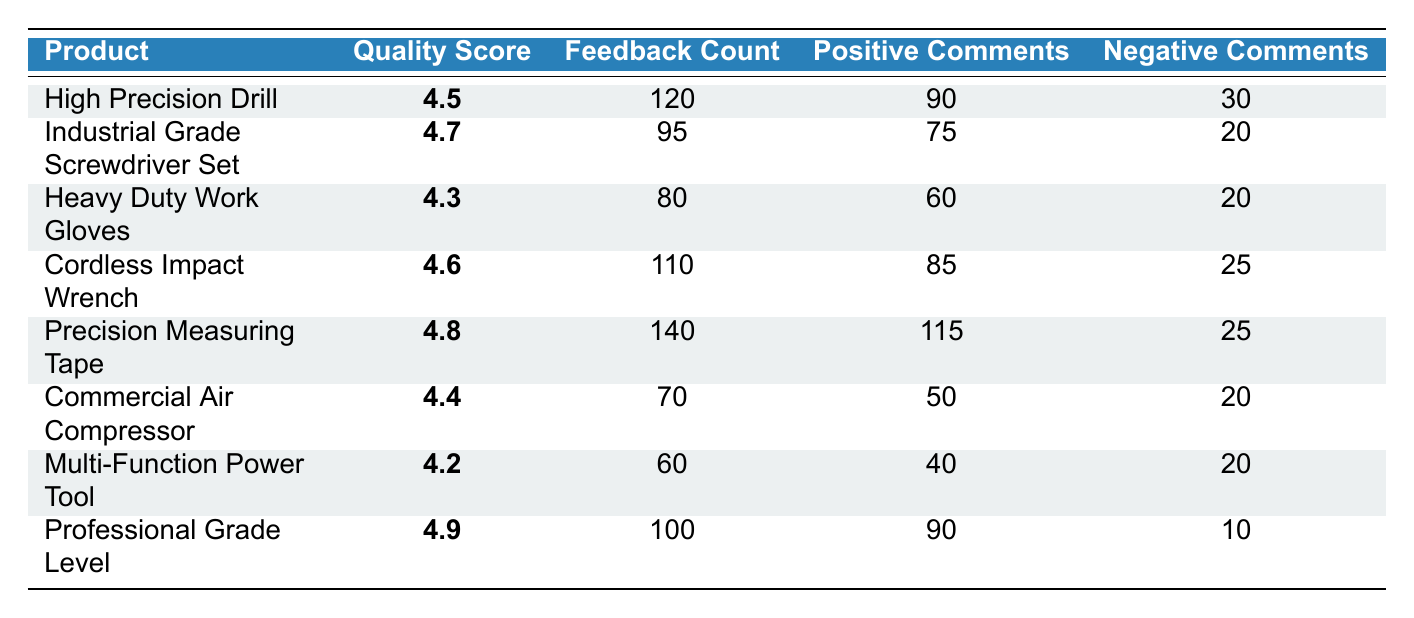What is the highest Quality Score among the products? The products listed have Quality Scores of 4.5, 4.7, 4.3, 4.6, 4.8, 4.4, 4.2, and 4.9. The highest of these values is 4.9 for the Professional Grade Level.
Answer: 4.9 Which product had the lowest number of Feedback Count? The products have Feedback Counts of 120, 95, 80, 110, 140, 70, 60, and 100. The lowest count is 60 for the Multi-Function Power Tool.
Answer: Multi-Function Power Tool What is the total number of Positive Comments across all products? The total number of Positive Comments can be computed by adding the Positive Comments of each product: (90 + 75 + 60 + 85 + 115 + 50 + 40 + 90) = 705.
Answer: 705 Is the Quality Score for the Heavy Duty Work Gloves greater than or equal to 4.5? The Quality Score for the Heavy Duty Work Gloves is 4.3, which is less than 4.5. Therefore, the statement is false.
Answer: No What is the difference between the highest and lowest Quality Scores? The highest Quality Score is 4.9 (Professional Grade Level) and the lowest is 4.2 (Multi-Function Power Tool). The difference is 4.9 - 4.2 = 0.7.
Answer: 0.7 Which product had the most Negative Comments? The Negative Comments for all products are 30, 20, 20, 25, 25, 20, 20, and 10. The highest count is 30 for the High Precision Drill.
Answer: High Precision Drill What percentage of comments for the Precision Measuring Tape were positive? The Precision Measuring Tape has 115 Positive Comments out of a total of 140 Feedback Count. The percentage is (115 / 140) * 100 = 82.14%.
Answer: 82.14% What is the average Quality Score of all products listed? Summing the Quality Scores (4.5 + 4.7 + 4.3 + 4.6 + 4.8 + 4.4 + 4.2 + 4.9 = 36.4) and dividing by the number of products (8), the average is 36.4 / 8 = 4.55.
Answer: 4.55 How many products scored above 4.5? The products with Quality Scores above 4.5 are Industrial Grade Screwdriver Set (4.7), Cordless Impact Wrench (4.6), Precision Measuring Tape (4.8), and Professional Grade Level (4.9). This makes a total of 4 products.
Answer: 4 Which product has the highest ratio of Positive to Negative Comments? The ratio can be calculated for each product by dividing Positive Comments by Negative Comments. The ratios are as follows: High Precision Drill (90/30=3.0), Industrial Grade Screwdriver Set (75/20=3.75), Heavy Duty Work Gloves (60/20=3.0), Cordless Impact Wrench (85/25=3.4), Precision Measuring Tape (115/25=4.6), Commercial Air Compressor (50/20=2.5), Multi-Function Power Tool (40/20=2.0), Professional Grade Level (90/10=9.0). The highest ratio is 9.0 for the Professional Grade Level.
Answer: Professional Grade Level 